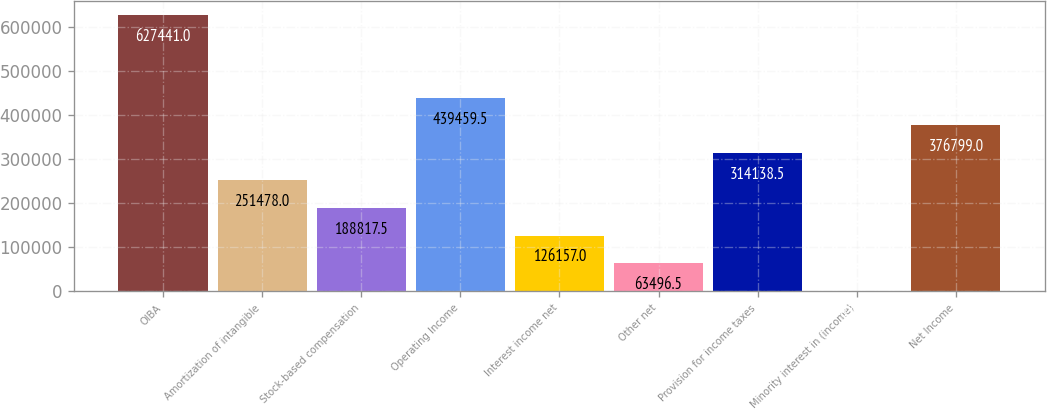Convert chart to OTSL. <chart><loc_0><loc_0><loc_500><loc_500><bar_chart><fcel>OIBA<fcel>Amortization of intangible<fcel>Stock-based compensation<fcel>Operating Income<fcel>Interest income net<fcel>Other net<fcel>Provision for income taxes<fcel>Minority interest in (income)<fcel>Net Income<nl><fcel>627441<fcel>251478<fcel>188818<fcel>439460<fcel>126157<fcel>63496.5<fcel>314138<fcel>836<fcel>376799<nl></chart> 